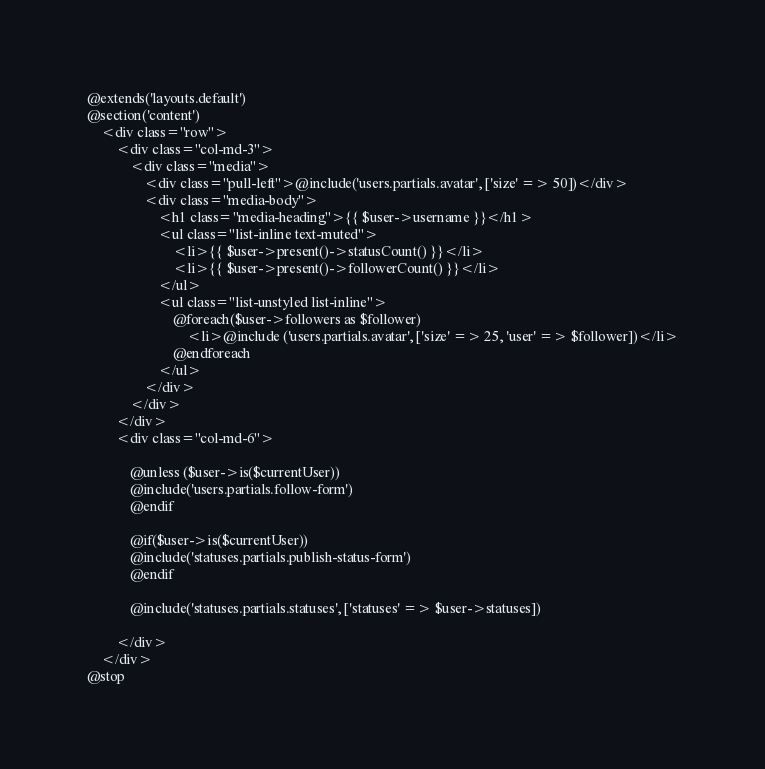Convert code to text. <code><loc_0><loc_0><loc_500><loc_500><_PHP_>@extends('layouts.default')
@section('content')
    <div class="row">
        <div class="col-md-3">
            <div class="media">
                <div class="pull-left">@include('users.partials.avatar', ['size' => 50])</div>
                <div class="media-body">
                    <h1 class="media-heading">{{ $user->username }}</h1>
                    <ul class="list-inline text-muted">
                        <li>{{ $user->present()->statusCount() }}</li>
                        <li>{{ $user->present()->followerCount() }}</li>
                    </ul>
                    <ul class="list-unstyled list-inline">
                        @foreach($user->followers as $follower)
                            <li>@include ('users.partials.avatar', ['size' => 25, 'user' => $follower])</li>
                        @endforeach
                    </ul>
                </div>
            </div>
        </div>
        <div class="col-md-6">

            @unless ($user->is($currentUser))
            @include('users.partials.follow-form')
            @endif

            @if($user->is($currentUser))
            @include('statuses.partials.publish-status-form')
            @endif

            @include('statuses.partials.statuses', ['statuses' => $user->statuses])

        </div>
    </div>
@stop</code> 